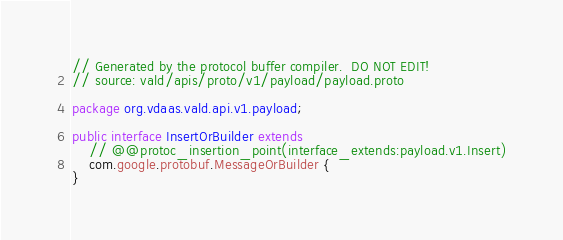Convert code to text. <code><loc_0><loc_0><loc_500><loc_500><_Java_>// Generated by the protocol buffer compiler.  DO NOT EDIT!
// source: vald/apis/proto/v1/payload/payload.proto

package org.vdaas.vald.api.v1.payload;

public interface InsertOrBuilder extends
    // @@protoc_insertion_point(interface_extends:payload.v1.Insert)
    com.google.protobuf.MessageOrBuilder {
}
</code> 